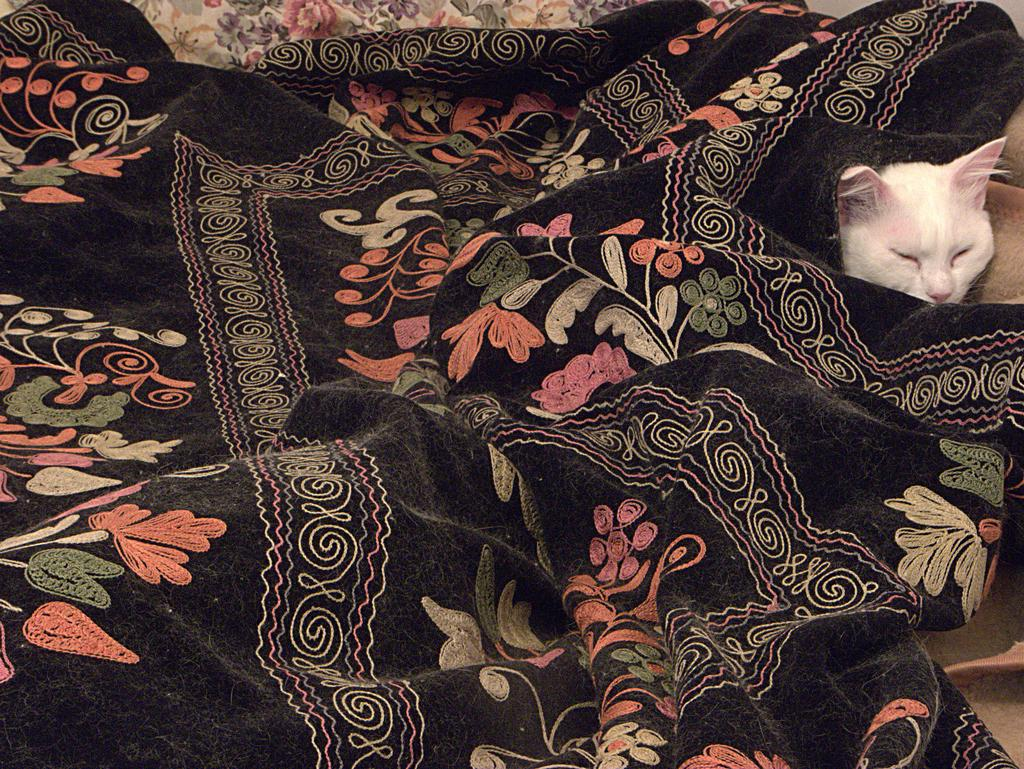What type of animal is in the image? There is a white cat in the image. What is covering the cat in the image? The cat has a black blanket on it. Can you describe the design on the black blanket? Unfortunately, the facts provided do not give any information about the design on the black blanket. Where is the cat's aunt sleeping in the image? There is no information about an aunt or any beds in the image. Is the cat in jail in the image? There is no indication of a jail or any confinement in the image. 